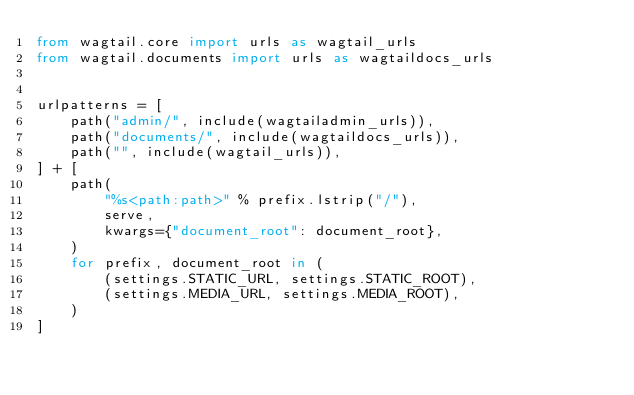Convert code to text. <code><loc_0><loc_0><loc_500><loc_500><_Python_>from wagtail.core import urls as wagtail_urls
from wagtail.documents import urls as wagtaildocs_urls


urlpatterns = [
    path("admin/", include(wagtailadmin_urls)),
    path("documents/", include(wagtaildocs_urls)),
    path("", include(wagtail_urls)),
] + [
    path(
        "%s<path:path>" % prefix.lstrip("/"),
        serve,
        kwargs={"document_root": document_root},
    )
    for prefix, document_root in (
        (settings.STATIC_URL, settings.STATIC_ROOT),
        (settings.MEDIA_URL, settings.MEDIA_ROOT),
    )
]
</code> 